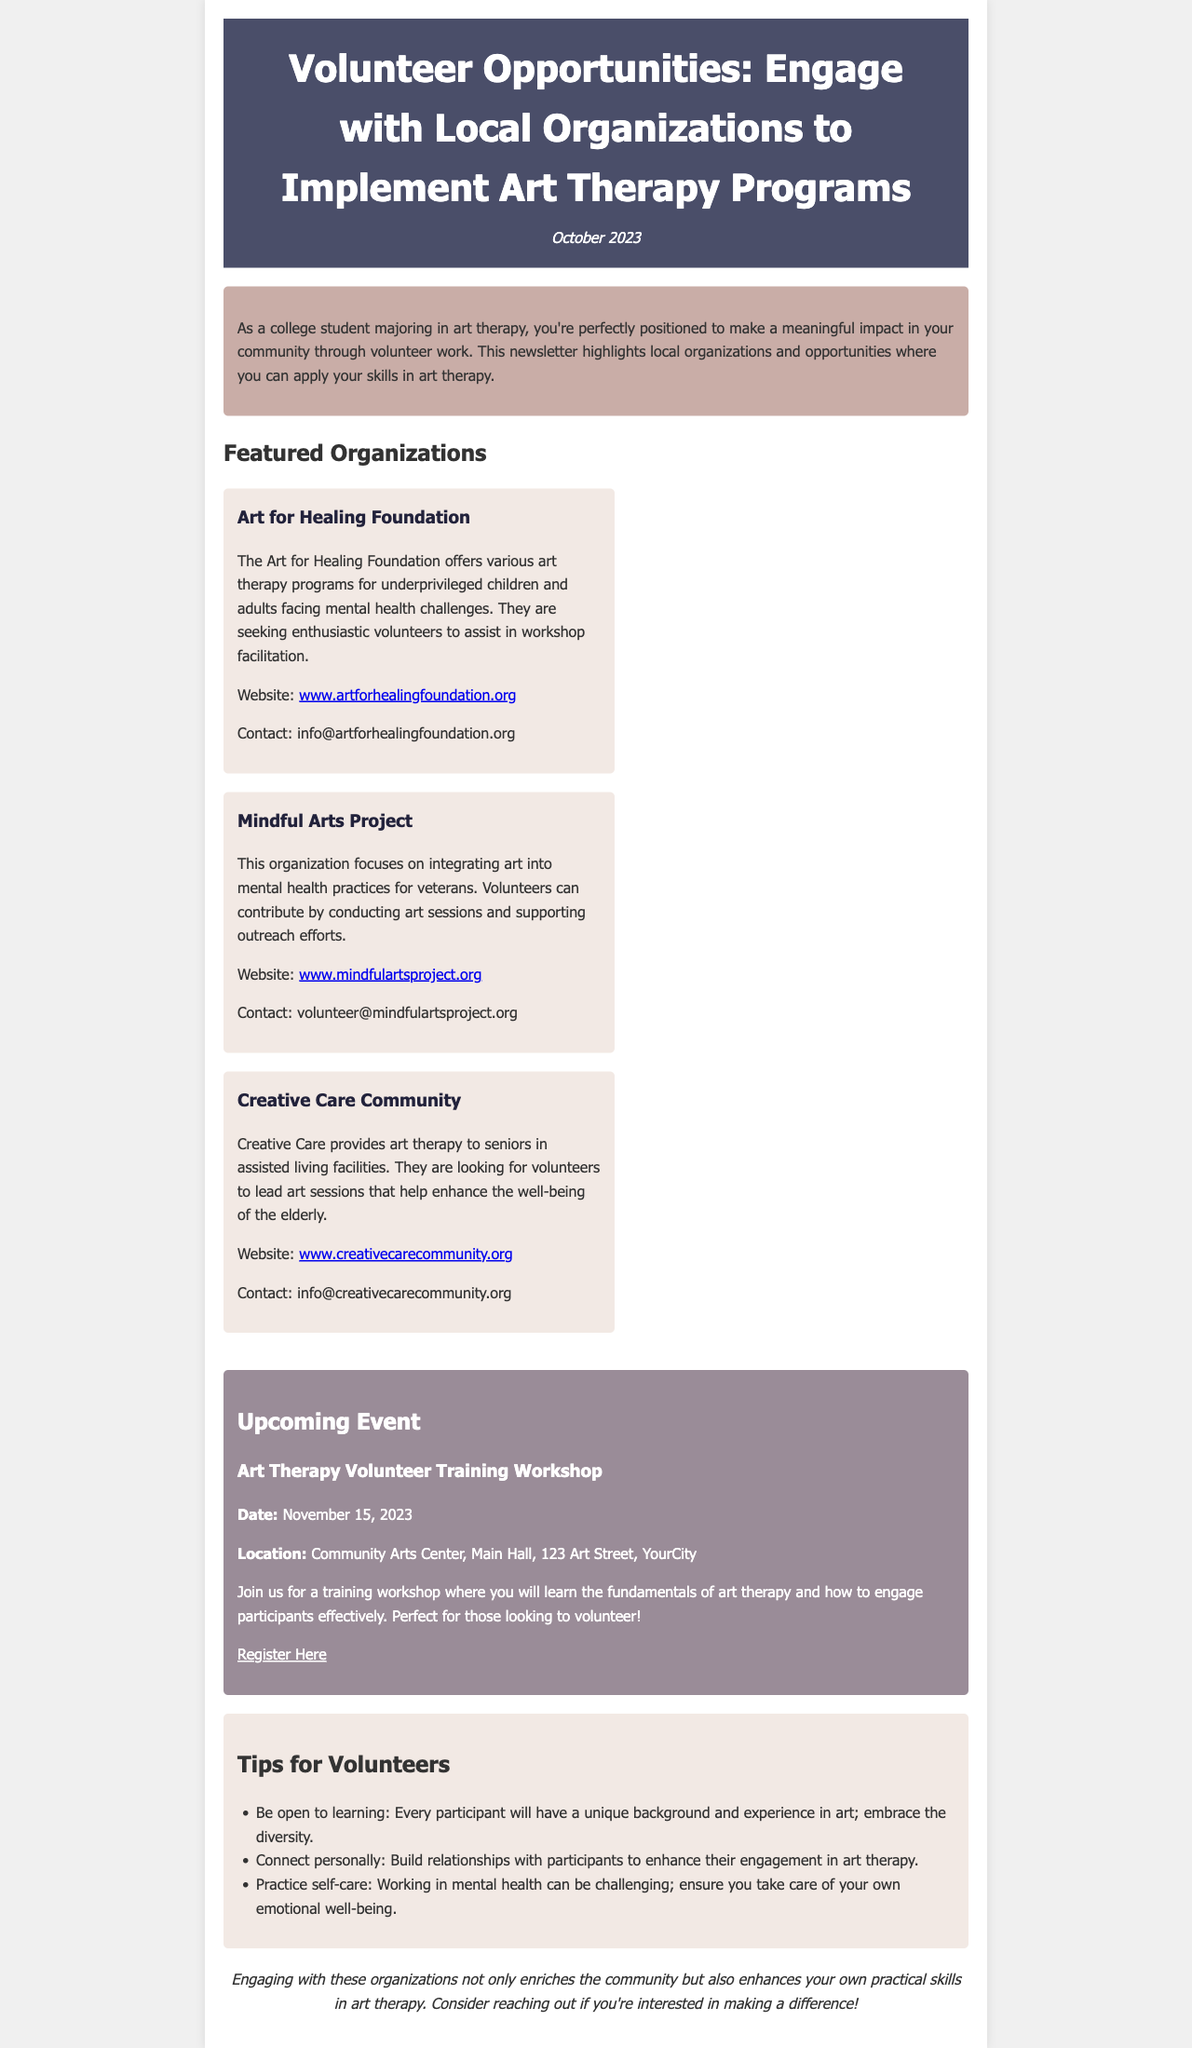What is the title of the newsletter? The title of the newsletter is prominently displayed at the top of the document, providing context about the content covered.
Answer: Volunteer Opportunities: Engage with Local Organizations to Implement Art Therapy Programs When is the Art Therapy Volunteer Training Workshop scheduled? The date for the workshop is listed in the events section, indicating when it will take place.
Answer: November 15, 2023 Which organization focuses on veterans in its programs? The organization focused on veterans is mentioned specifically in the section about featured organizations.
Answer: Mindful Arts Project What is the website for the Art for Healing Foundation? The website for the organization is provided to allow interested volunteers to find more information.
Answer: www.artforhealingfoundation.org What networking advantage does engaging with these organizations provide? The document implies that engaging with local organizations helps enhance practical skills, indicating a dual benefit for volunteers.
Answer: Enriches the community and enhances practical skills How many featured organizations are listed in the newsletter? The number of organizations highlighted is given in the featured organizations section, indicating the scope of opportunities available.
Answer: Three What is one tip for volunteers mentioned in the newsletter? Tips for volunteers are provided to guide them in their engagement, and one specific tip can be extracted from this section.
Answer: Be open to learning Where is the upcoming event taking place? The location of the training workshop is mentioned, indicating where interested participants need to go.
Answer: Community Arts Center, Main Hall, 123 Art Street, YourCity 